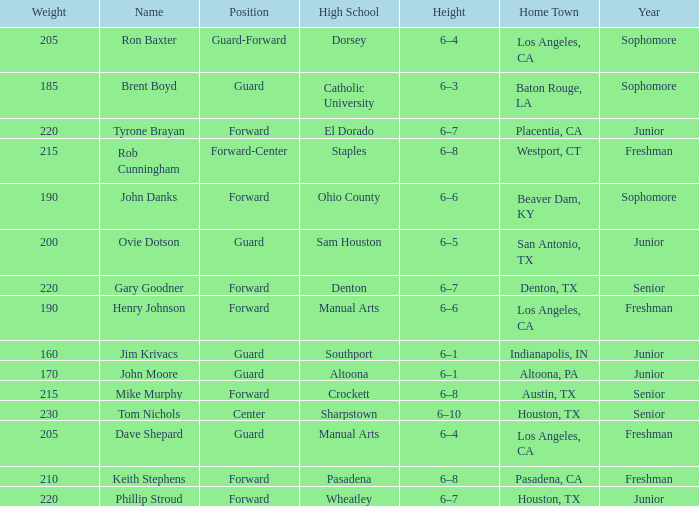What is the role in a year with a first-year student, and a weight exceeding 210? Forward-Center. Write the full table. {'header': ['Weight', 'Name', 'Position', 'High School', 'Height', 'Home Town', 'Year'], 'rows': [['205', 'Ron Baxter', 'Guard-Forward', 'Dorsey', '6–4', 'Los Angeles, CA', 'Sophomore'], ['185', 'Brent Boyd', 'Guard', 'Catholic University', '6–3', 'Baton Rouge, LA', 'Sophomore'], ['220', 'Tyrone Brayan', 'Forward', 'El Dorado', '6–7', 'Placentia, CA', 'Junior'], ['215', 'Rob Cunningham', 'Forward-Center', 'Staples', '6–8', 'Westport, CT', 'Freshman'], ['190', 'John Danks', 'Forward', 'Ohio County', '6–6', 'Beaver Dam, KY', 'Sophomore'], ['200', 'Ovie Dotson', 'Guard', 'Sam Houston', '6–5', 'San Antonio, TX', 'Junior'], ['220', 'Gary Goodner', 'Forward', 'Denton', '6–7', 'Denton, TX', 'Senior'], ['190', 'Henry Johnson', 'Forward', 'Manual Arts', '6–6', 'Los Angeles, CA', 'Freshman'], ['160', 'Jim Krivacs', 'Guard', 'Southport', '6–1', 'Indianapolis, IN', 'Junior'], ['170', 'John Moore', 'Guard', 'Altoona', '6–1', 'Altoona, PA', 'Junior'], ['215', 'Mike Murphy', 'Forward', 'Crockett', '6–8', 'Austin, TX', 'Senior'], ['230', 'Tom Nichols', 'Center', 'Sharpstown', '6–10', 'Houston, TX', 'Senior'], ['205', 'Dave Shepard', 'Guard', 'Manual Arts', '6–4', 'Los Angeles, CA', 'Freshman'], ['210', 'Keith Stephens', 'Forward', 'Pasadena', '6–8', 'Pasadena, CA', 'Freshman'], ['220', 'Phillip Stroud', 'Forward', 'Wheatley', '6–7', 'Houston, TX', 'Junior']]} 